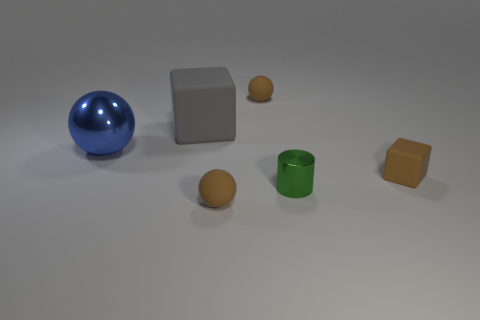Add 1 large gray things. How many objects exist? 7 Subtract all blocks. How many objects are left? 4 Add 4 small metallic cylinders. How many small metallic cylinders exist? 5 Subtract 0 red cylinders. How many objects are left? 6 Subtract all large rubber balls. Subtract all large blue metal balls. How many objects are left? 5 Add 6 tiny rubber blocks. How many tiny rubber blocks are left? 7 